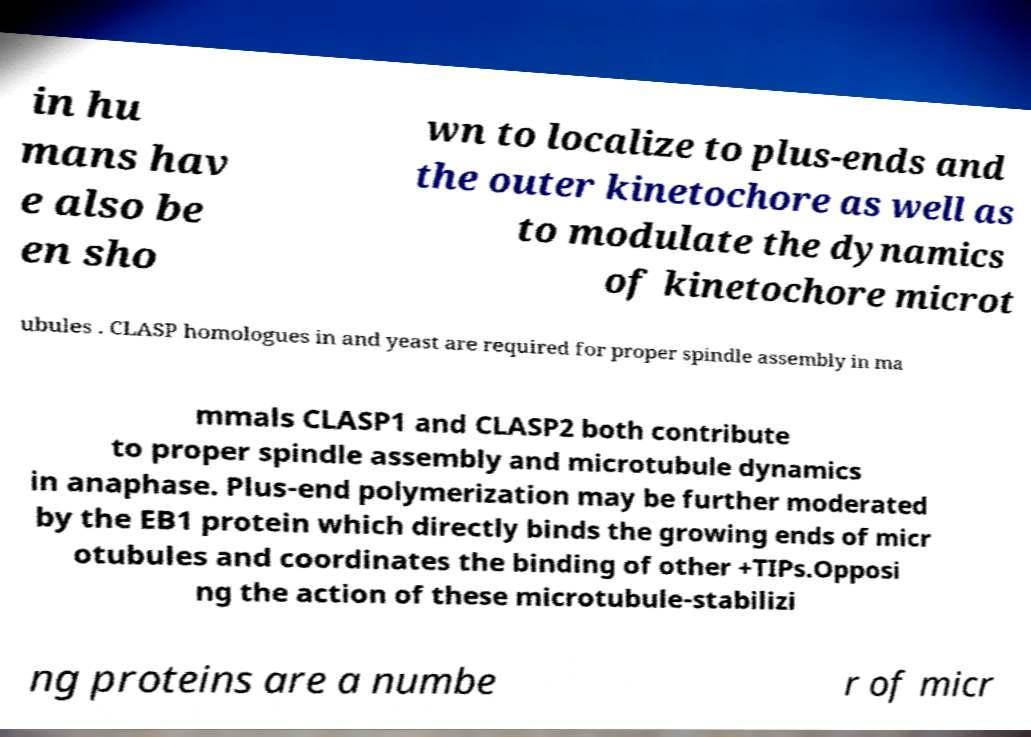I need the written content from this picture converted into text. Can you do that? in hu mans hav e also be en sho wn to localize to plus-ends and the outer kinetochore as well as to modulate the dynamics of kinetochore microt ubules . CLASP homologues in and yeast are required for proper spindle assembly in ma mmals CLASP1 and CLASP2 both contribute to proper spindle assembly and microtubule dynamics in anaphase. Plus-end polymerization may be further moderated by the EB1 protein which directly binds the growing ends of micr otubules and coordinates the binding of other +TIPs.Opposi ng the action of these microtubule-stabilizi ng proteins are a numbe r of micr 